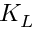Convert formula to latex. <formula><loc_0><loc_0><loc_500><loc_500>K _ { L }</formula> 